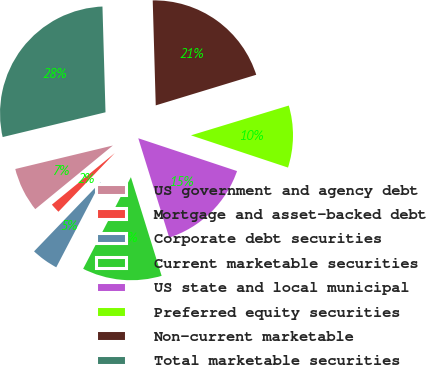<chart> <loc_0><loc_0><loc_500><loc_500><pie_chart><fcel>US government and agency debt<fcel>Mortgage and asset-backed debt<fcel>Corporate debt securities<fcel>Current marketable securities<fcel>US state and local municipal<fcel>Preferred equity securities<fcel>Non-current marketable<fcel>Total marketable securities<nl><fcel>7.17%<fcel>1.89%<fcel>4.53%<fcel>12.45%<fcel>15.09%<fcel>9.81%<fcel>20.75%<fcel>28.3%<nl></chart> 